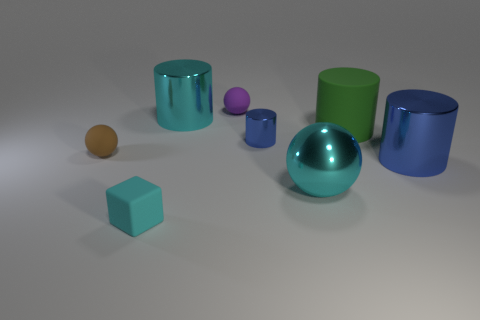What is the texture of the objects, and does it differ among them? The objects share a similar smooth and glossy texture, reflecting light and providing them with a shiny appearance. The consistency of texture across all objects adds a sense of unity to the image despite the varying colors and shapes. 